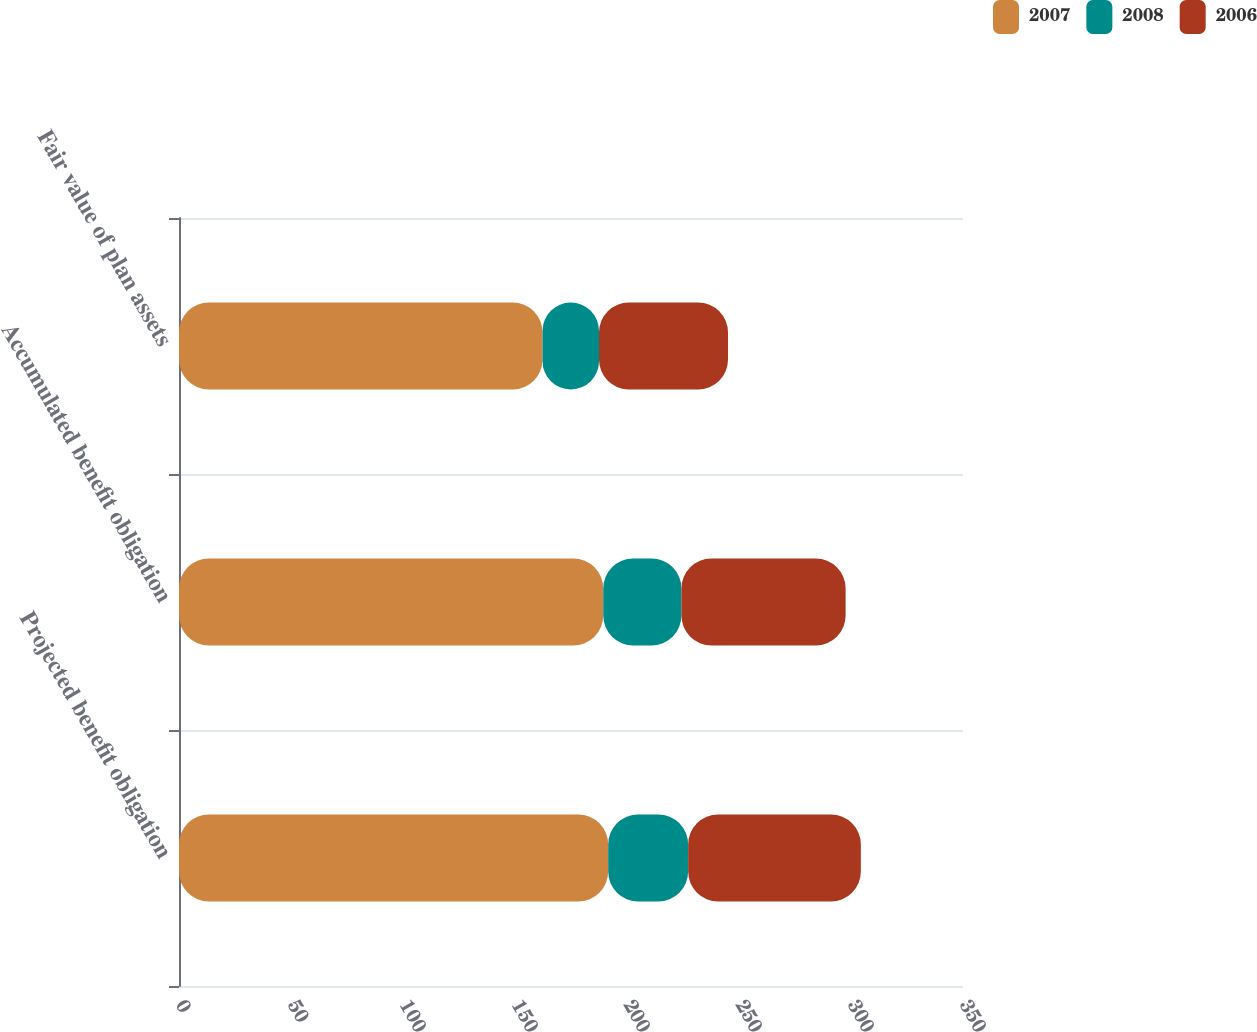<chart> <loc_0><loc_0><loc_500><loc_500><stacked_bar_chart><ecel><fcel>Projected benefit obligation<fcel>Accumulated benefit obligation<fcel>Fair value of plan assets<nl><fcel>2007<fcel>191.6<fcel>189.4<fcel>162.3<nl><fcel>2008<fcel>35.7<fcel>34.9<fcel>25.2<nl><fcel>2006<fcel>77.1<fcel>73.3<fcel>57.6<nl></chart> 